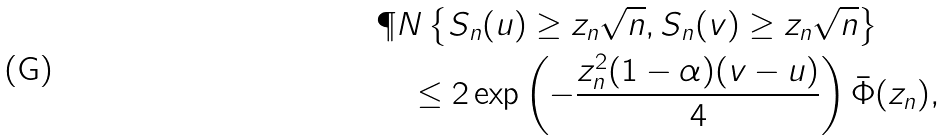<formula> <loc_0><loc_0><loc_500><loc_500>& \P N \left \{ S _ { n } ( u ) \geq z _ { n } \sqrt { n } , S _ { n } ( v ) \geq z _ { n } \sqrt { n } \right \} \\ & \quad \leq 2 \exp \left ( - \frac { z _ { n } ^ { 2 } ( 1 - \alpha ) ( v - u ) } { 4 } \right ) \bar { \Phi } ( z _ { n } ) ,</formula> 